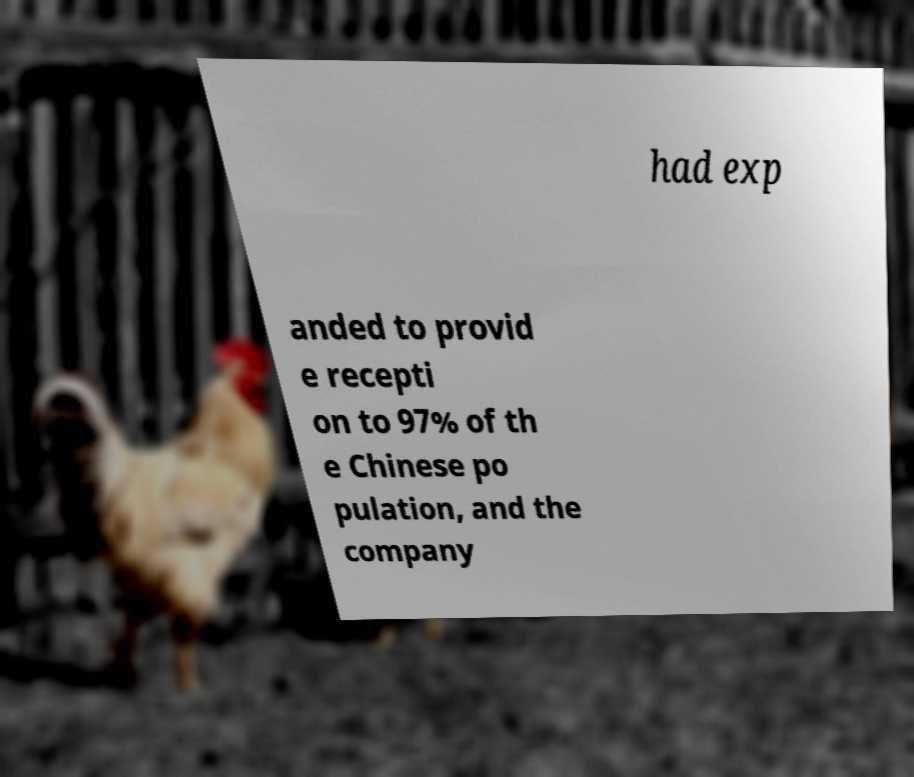Can you read and provide the text displayed in the image?This photo seems to have some interesting text. Can you extract and type it out for me? had exp anded to provid e recepti on to 97% of th e Chinese po pulation, and the company 